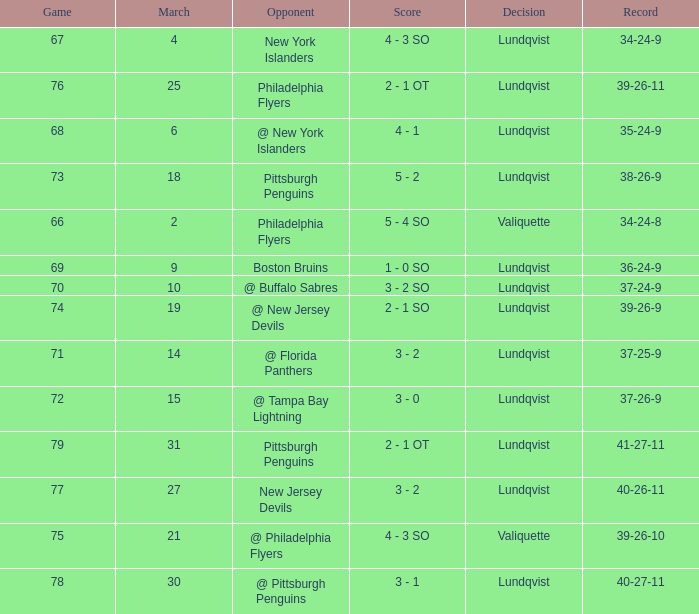In which match was the score under 69 when the march was greater than 2 and the opponents were the new york islanders? 4 - 3 SO. 